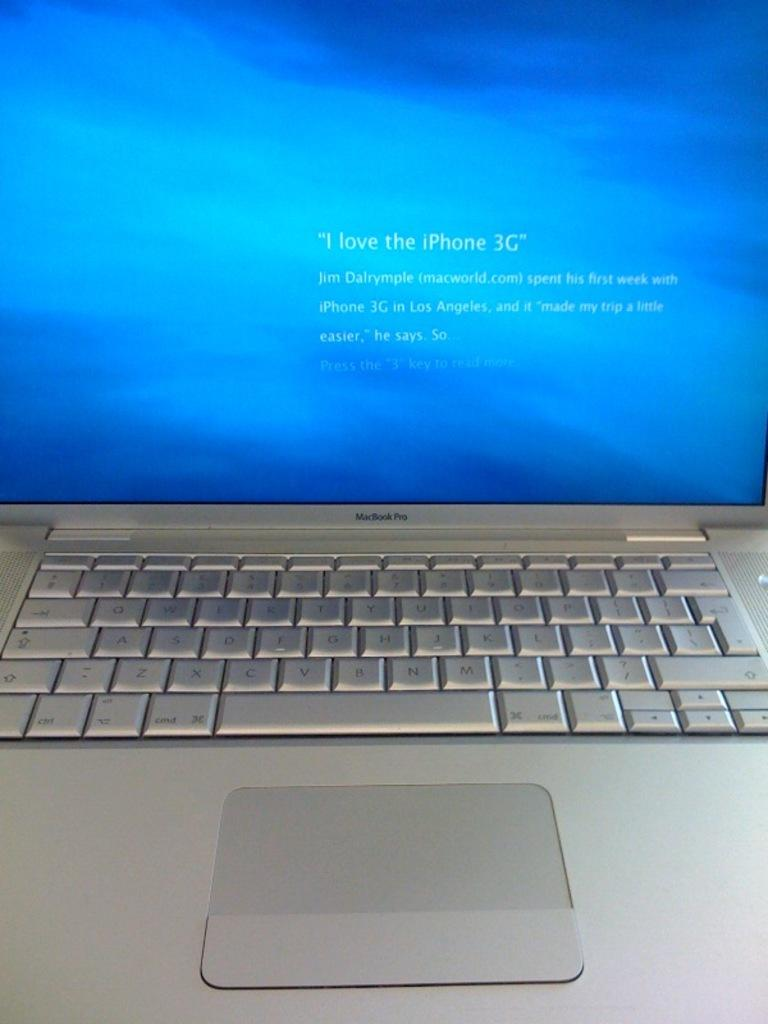<image>
Relay a brief, clear account of the picture shown. A mac laptop is shown with text that reads "I love iPhone 3G" on its monitor. 